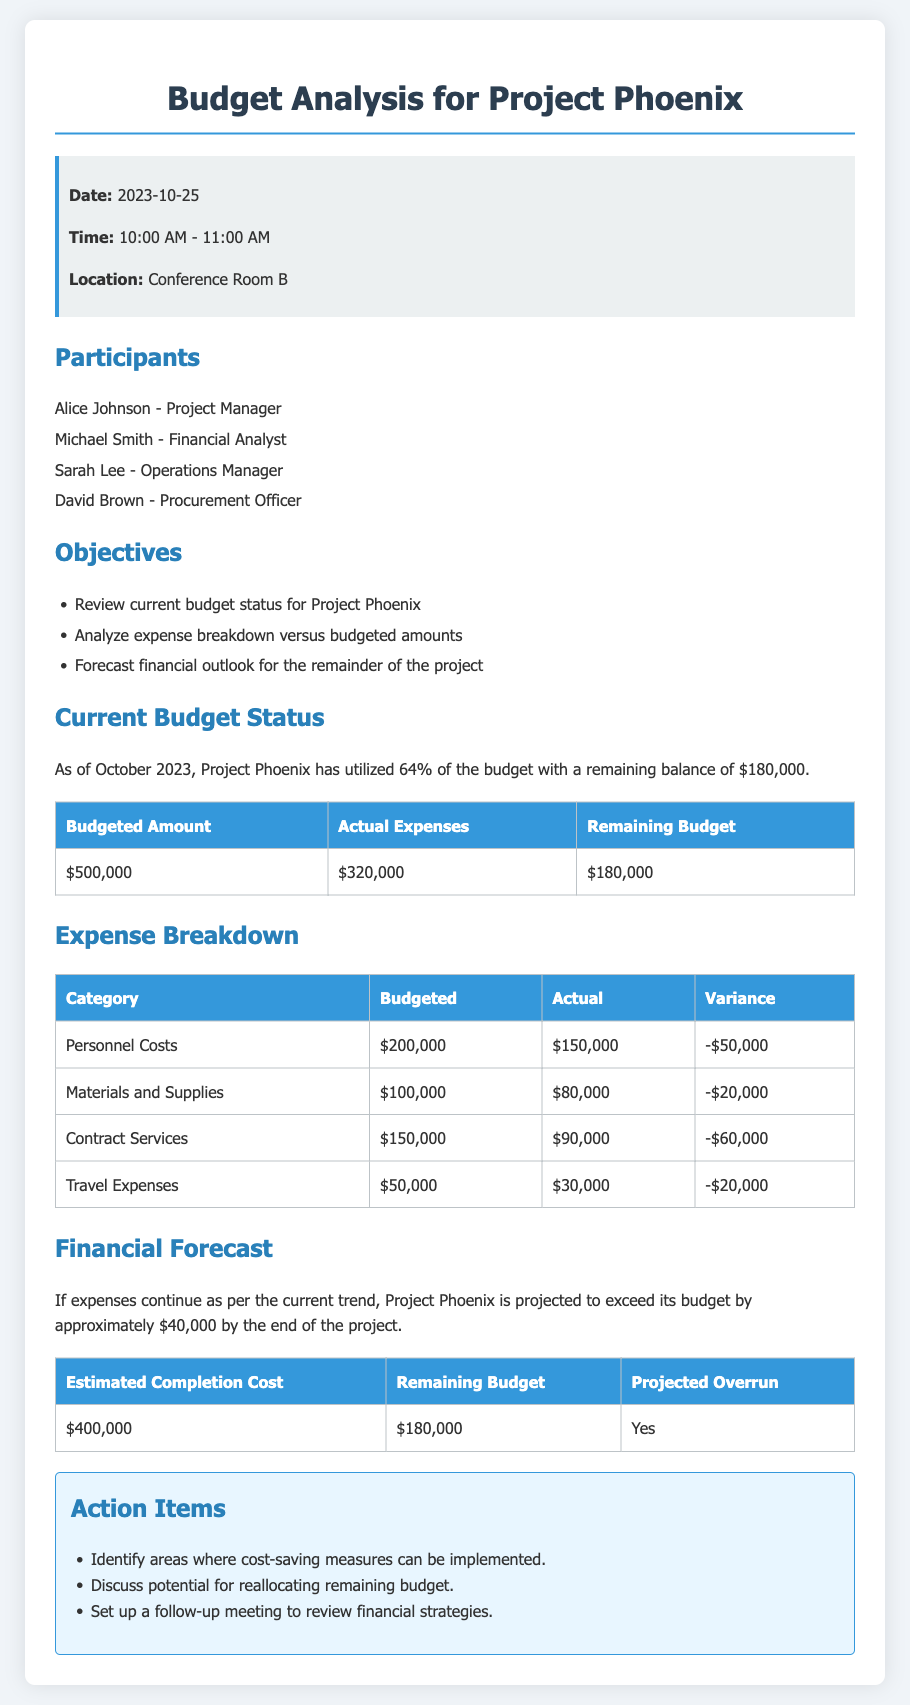What is the date of the budget analysis meeting? The date is stated in the info box section of the document.
Answer: 2023-10-25 Who is the financial analyst for Project Phoenix? The participants list includes names and their roles; the financial analyst is specifically mentioned.
Answer: Michael Smith What percentage of the budget has been utilized up to October 2023? This percentage is given directly in the current budget status section.
Answer: 64% What is the remaining budget for Project Phoenix? The remaining budget is detailed in the current budget status table.
Answer: $180,000 What category has the highest actual expenses compared to budgeted amounts? A comparison of actual versus budgeted amounts in the expense breakdown reveals which category overspent the most.
Answer: Personnel Costs What is the projected overrun amount for the project? The financial forecast section provides an overview of the projected financials and confirms the overrun amount.
Answer: Yes How much have materials and supplies been budgeted for? The expense breakdown table lists budgeted amounts for each category, including materials.
Answer: $100,000 What is the estimated completion cost for Project Phoenix? The estimated completion cost is stated in the financial forecast section of the document.
Answer: $400,000 What action item concerns cost-saving measures? The action items section outlines specific tasks, one of which relates to cost-saving.
Answer: Identify areas where cost-saving measures can be implemented 